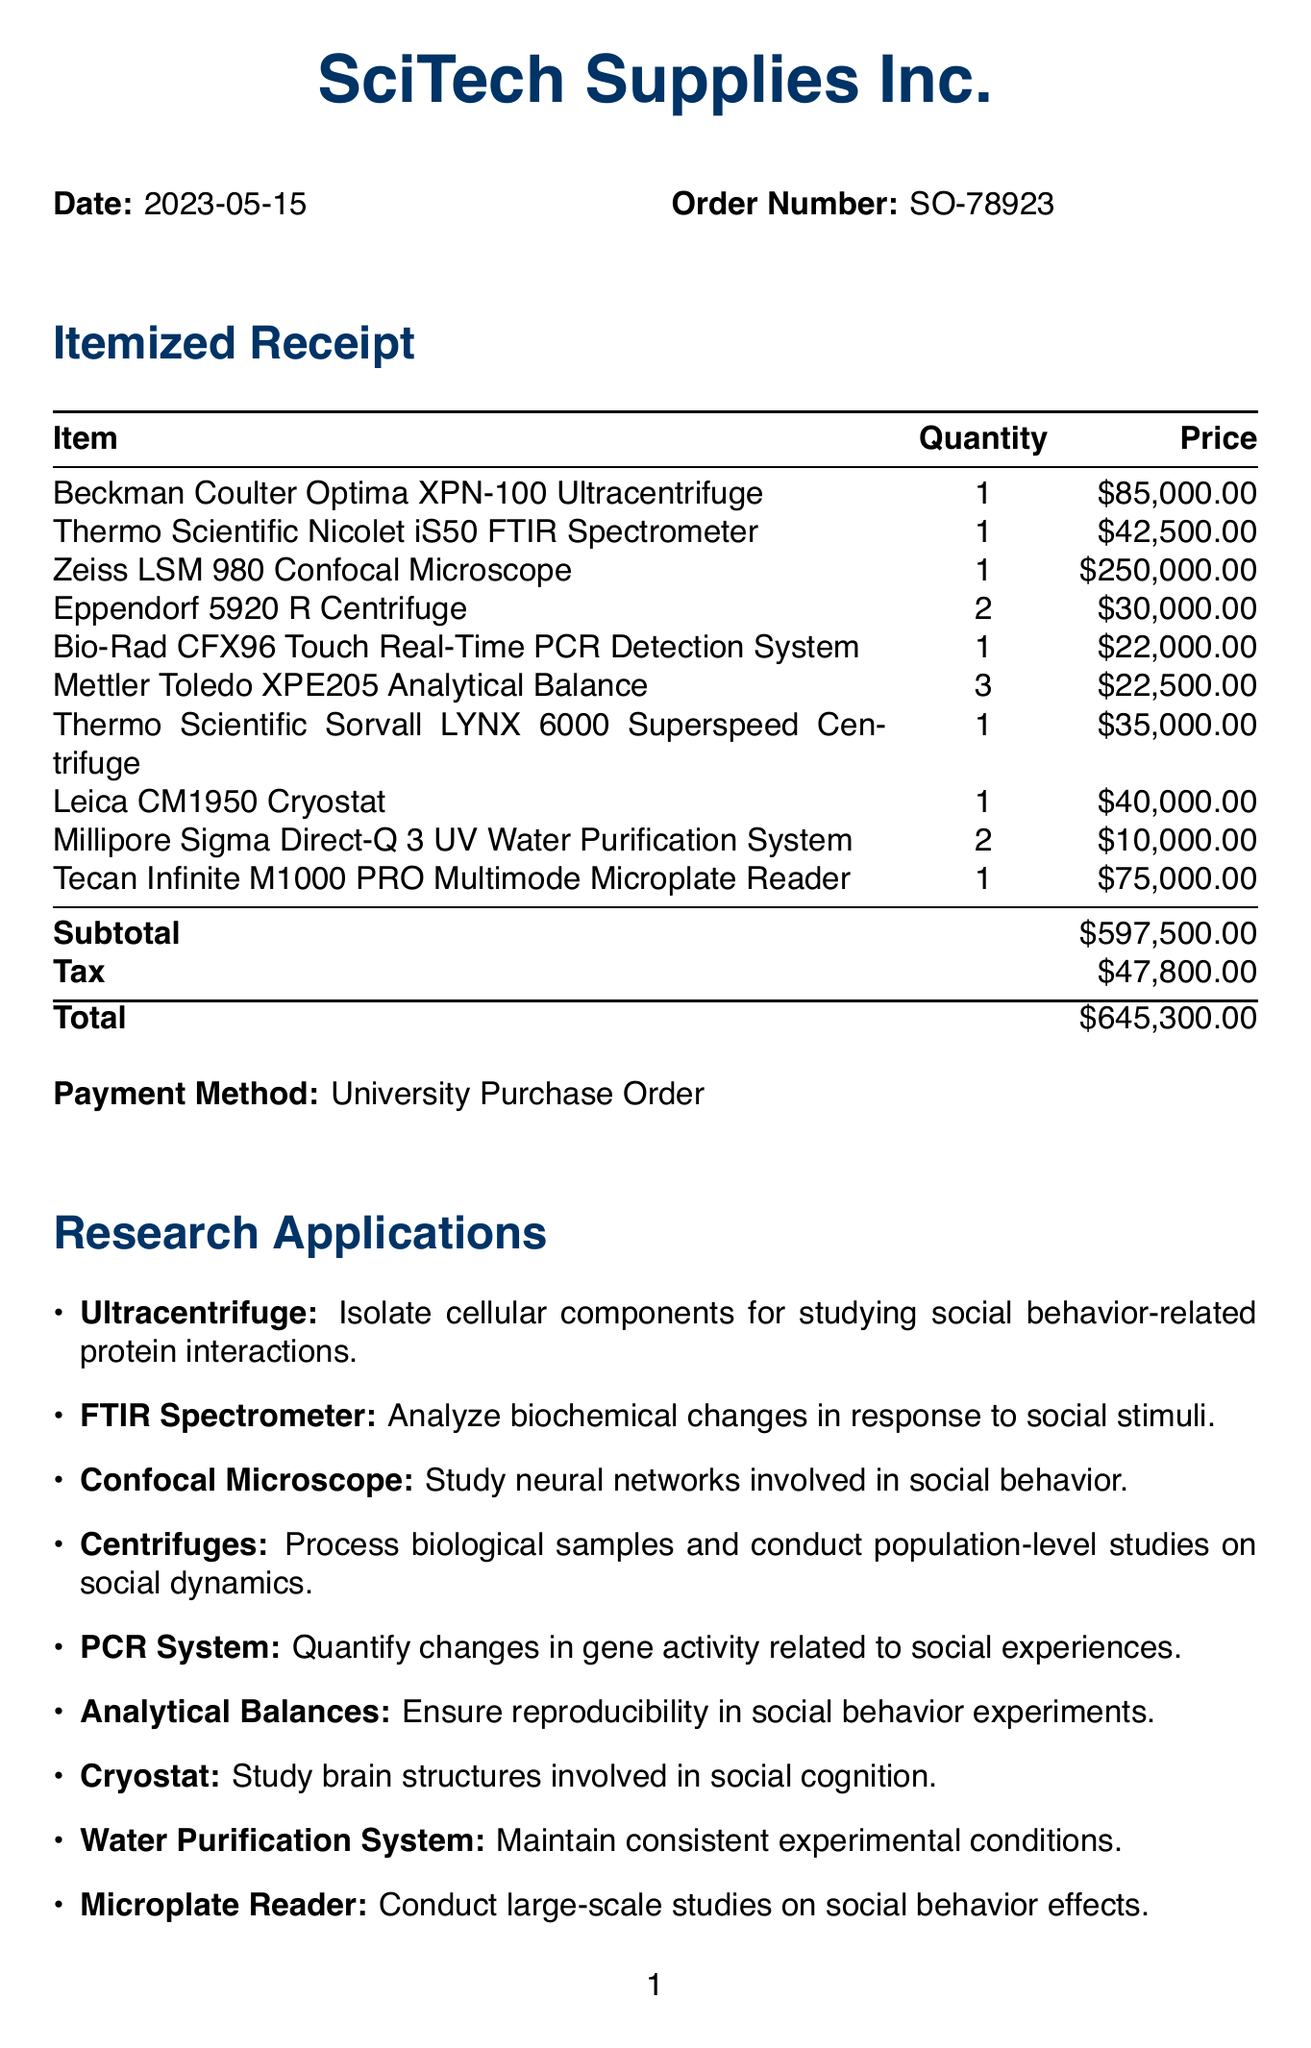what is the total amount spent on the laboratory equipment? The total amount of the purchase is listed at the bottom of the receipt, which includes subtotal and tax.
Answer: $645,300.00 when was the equipment purchased? The purchase date is specified at the beginning of the receipt, indicating when the transaction took place.
Answer: 2023-05-15 how many Eppendorf 5920 R Centrifuge units were purchased? The quantity for the Eppendorf 5920 R Centrifuge is mentioned alongside the item description in the receipt.
Answer: 2 which company issued the receipt? The company name is prominently displayed at the top of the document, indicating the source of the receipt.
Answer: SciTech Supplies Inc what is the order number for this purchase? The order number is explicitly noted in the document, allowing for tracking and reference of the transaction.
Answer: SO-78923 how much does the Zeiss LSM 980 Confocal Microscope cost? The price of the Zeiss LSM 980 Confocal Microscope is provided in the itemized list, detailing the financial aspects of the purchase.
Answer: 250,000.00 what are the additional notes about the equipment acquired? Additional notes provide context about the purpose of the equipment purchase, emphasizing the research focus of the center.
Answer: Equipment acquired for the new Social Neuroscience Research Center. Focus on quantitative analysis of biological and neurological aspects of social behavior to provide empirical evidence for or against current social theories how many types of centrifuges were purchased? The count of different centrifuge models is relevant to understanding the variety of equipment obtained.
Answer: 3 